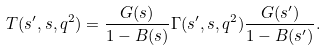<formula> <loc_0><loc_0><loc_500><loc_500>T ( s ^ { \prime } , s , q ^ { 2 } ) = \frac { G ( s ) } { 1 - B ( s ) } \Gamma ( s ^ { \prime } , s , q ^ { 2 } ) \frac { G ( s ^ { \prime } ) } { 1 - B ( s ^ { \prime } ) } .</formula> 